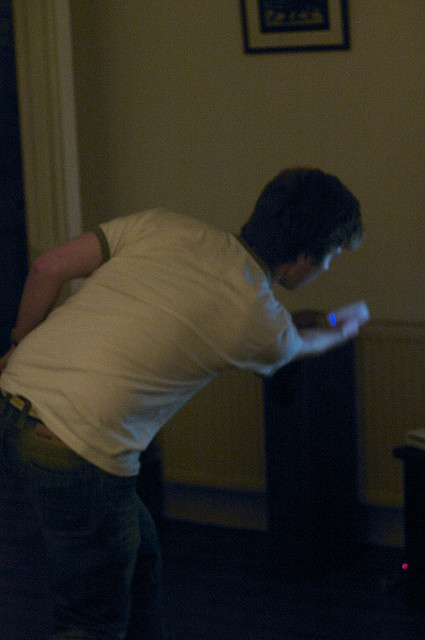Describe the objects in this image and their specific colors. I can see people in black and gray tones and remote in black, gray, and navy tones in this image. 